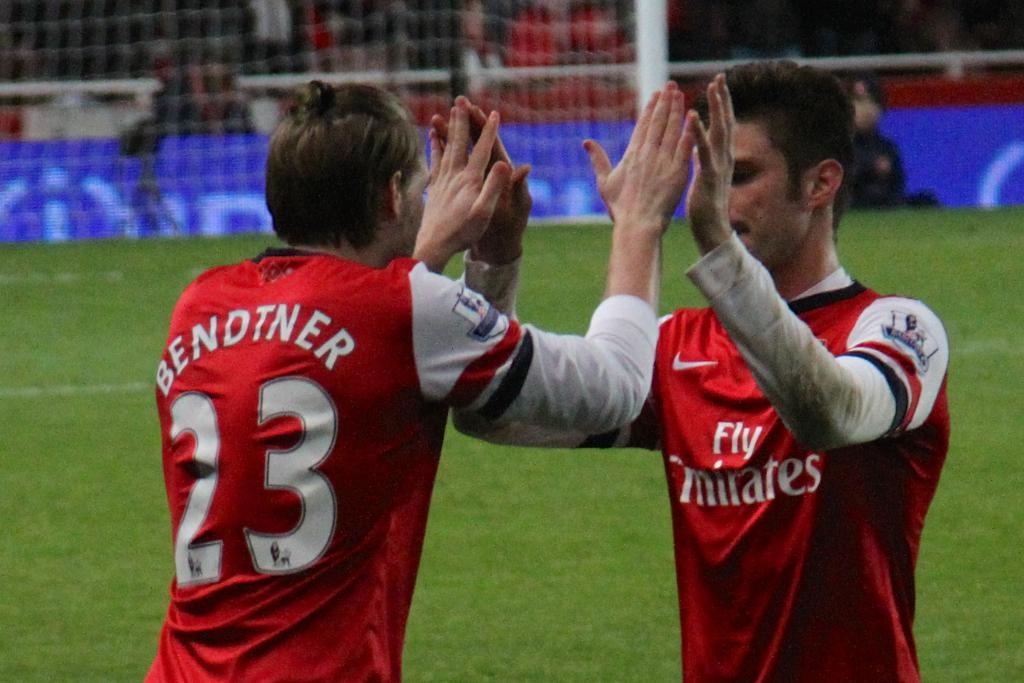<image>
Describe the image concisely. Two men high five one another while one wears a number twenty three jersey. 